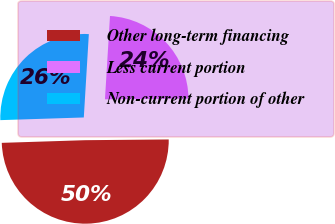<chart> <loc_0><loc_0><loc_500><loc_500><pie_chart><fcel>Other long-term financing<fcel>Less current portion<fcel>Non-current portion of other<nl><fcel>49.63%<fcel>23.9%<fcel>26.47%<nl></chart> 